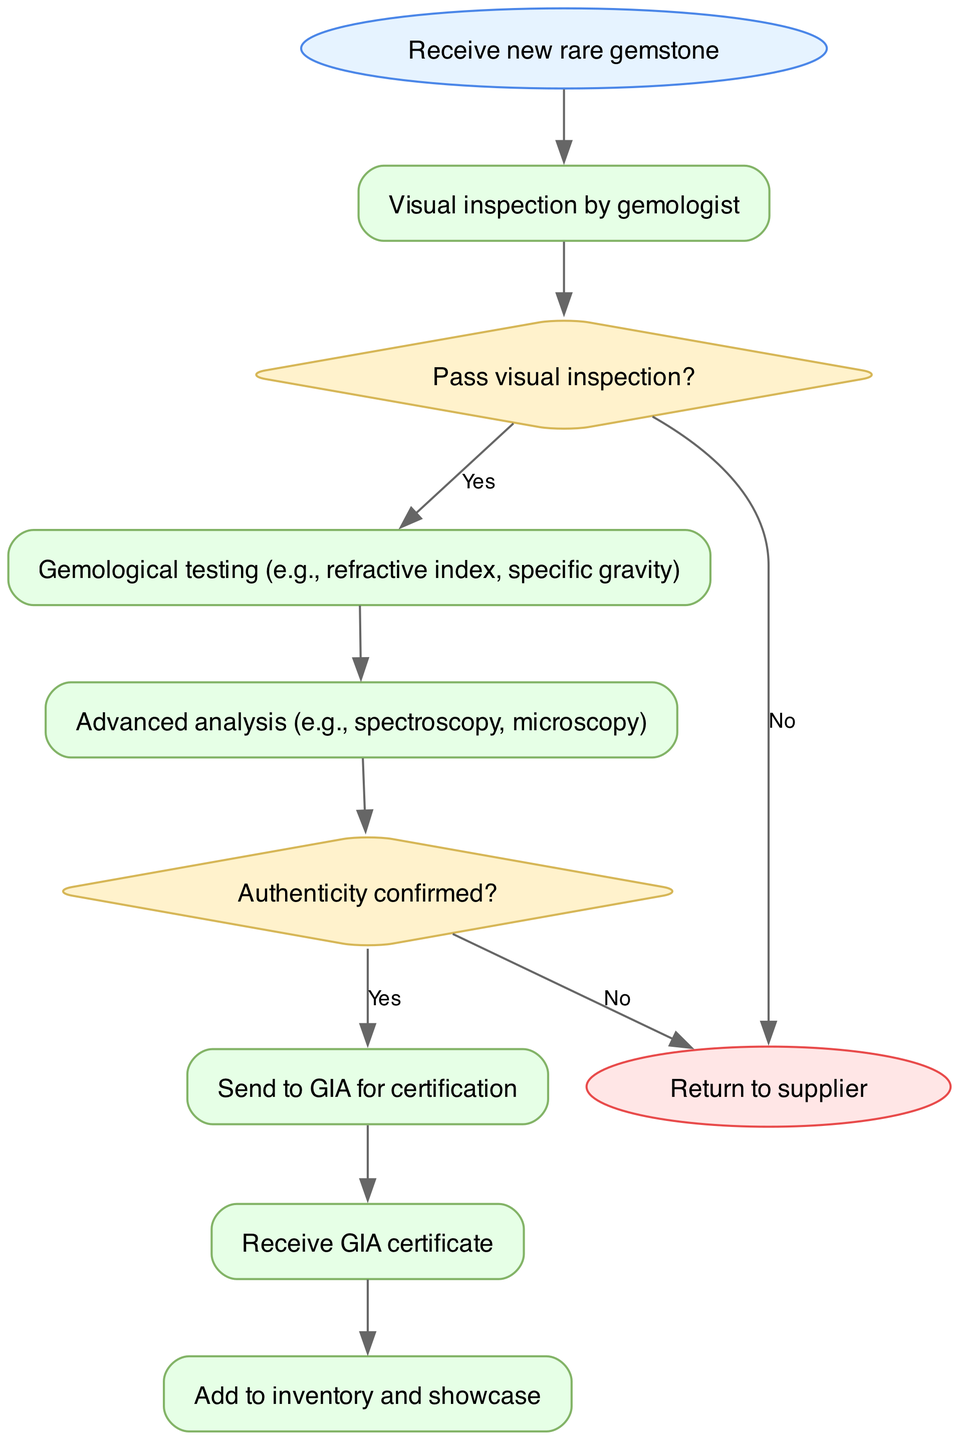What is the first step in the process? The diagram clearly shows that the first step is labeled "Receive new rare gemstone". This is the initial node from which the flowchart starts.
Answer: Receive new rare gemstone How many decisions are present in the diagram? By counting the diamond-shaped nodes, we can see there are two decisions in the flowchart: "Pass visual inspection?" and "Authenticity confirmed?". Thus, the total is two.
Answer: 2 What happens if the visual inspection fails? The diagram indicates that if the visual inspection does not pass (indicated by the "No" edge), it leads to the "Return to supplier" node, effectively ending the process for that gemstone.
Answer: Return to supplier What are the two types of analyses performed after the visual inspection? Following the visual inspection, the diagram shows two analyses: "Gemological testing" and "Advanced analysis". These steps are necessary to verify the gemstone's quality and authenticity.
Answer: Gemological testing, Advanced analysis What is the last step before adding the gemstone to inventory? The last step before adding the gemstone to inventory is shown in the diagram as "Receive GIA certificate", which occurs after sending the gemstone for certification.
Answer: Receive GIA certificate What is the outcome when authenticity is not confirmed? According to the diagram, if the authenticity is not confirmed (indicated by a "No" decision), the flow leads directly to the "Return to supplier" node, indicating that the gemstone will not proceed further in the quality control process.
Answer: Return to supplier How many nodes are labeled as steps in the flowchart? By reviewing the flowchart, we can identify six nodes labeled as steps: "Receive new rare gemstone", "Visual inspection by gemologist", "Gemological testing", "Advanced analysis", "Send to GIA for certification", and "Receive GIA certificate". This totals to six steps.
Answer: 6 What action is taken if the authenticity of the gemstone is confirmed? The diagram indicates that if the authenticity of the gemstone is confirmed (marked by a "Yes" decision), the process continues to the "Send to GIA for certification" step, which is the next significant action.
Answer: Send to GIA for certification 